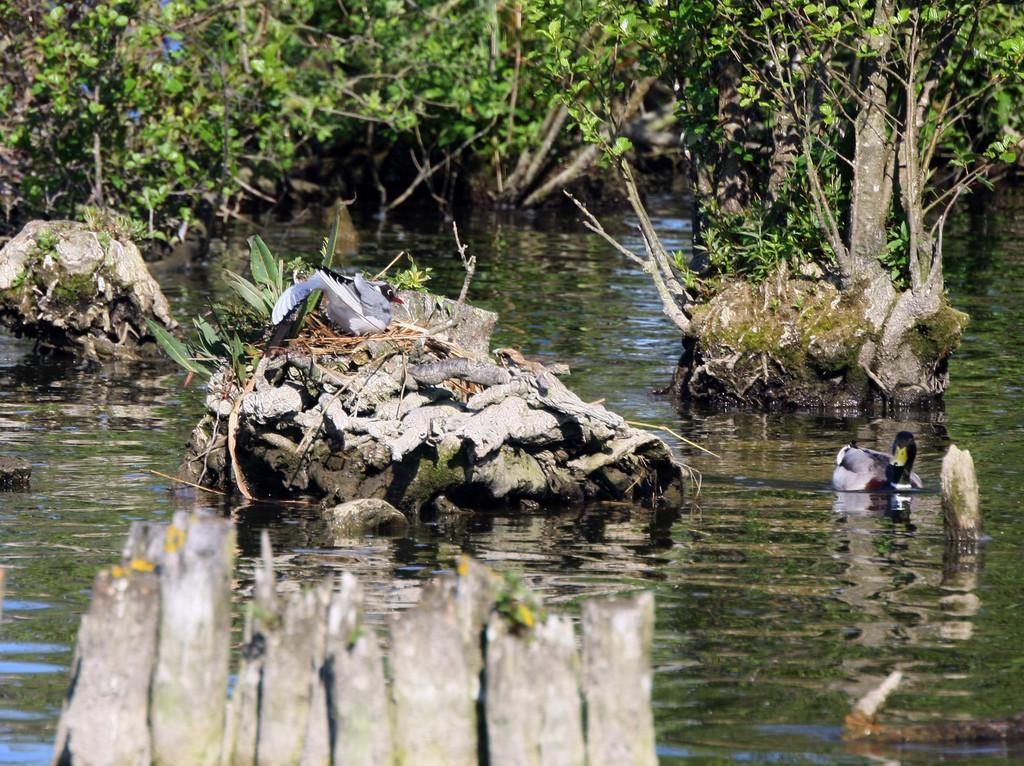What type of vegetation can be seen in the image? There are trees in the image. What else is present in the image besides trees? There is water and a duck on the right side of the image. Can you describe the position of the second duck in the image? There is a duck in the center of the image, on a tree. How would you describe the overall appearance of the image? The background of the image is blurred. What type of experience does the lawyer have in the image? There is no lawyer present in the image, so it is not possible to determine their experience. 